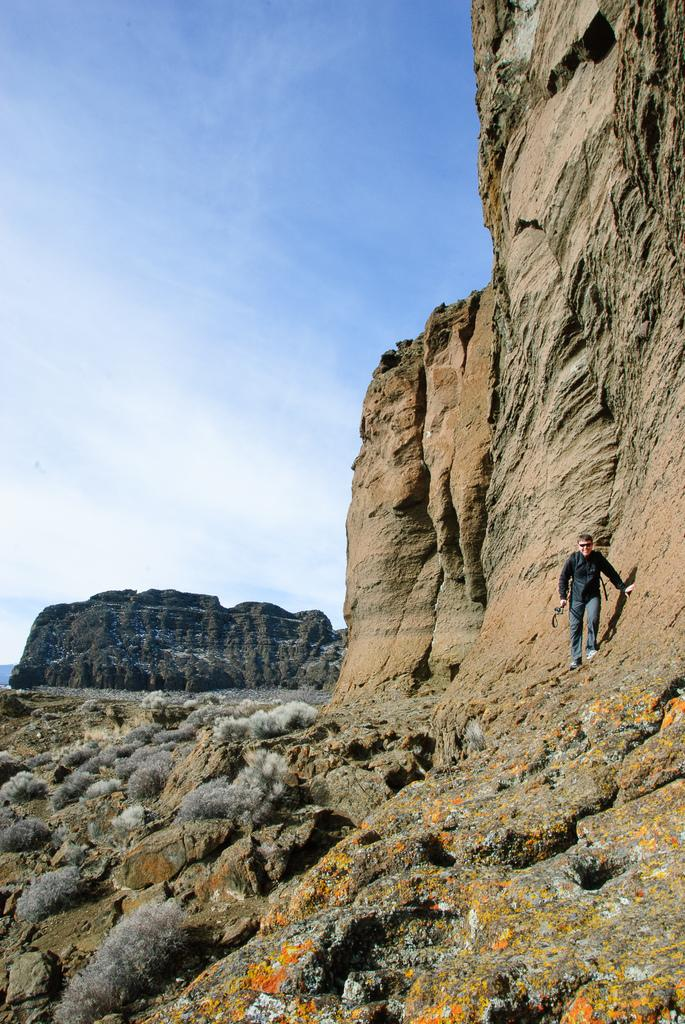What is the main subject of the image? There is a person standing in the image. What type of landscape can be seen in the image? The image appears to depict hills. What part of the natural environment is visible in the image? The sky is visible in the image. What type of sofa can be seen in the image? There is no sofa present in the image. What is the person's tendency in the image? The image does not provide information about the person's tendency or behavior. 